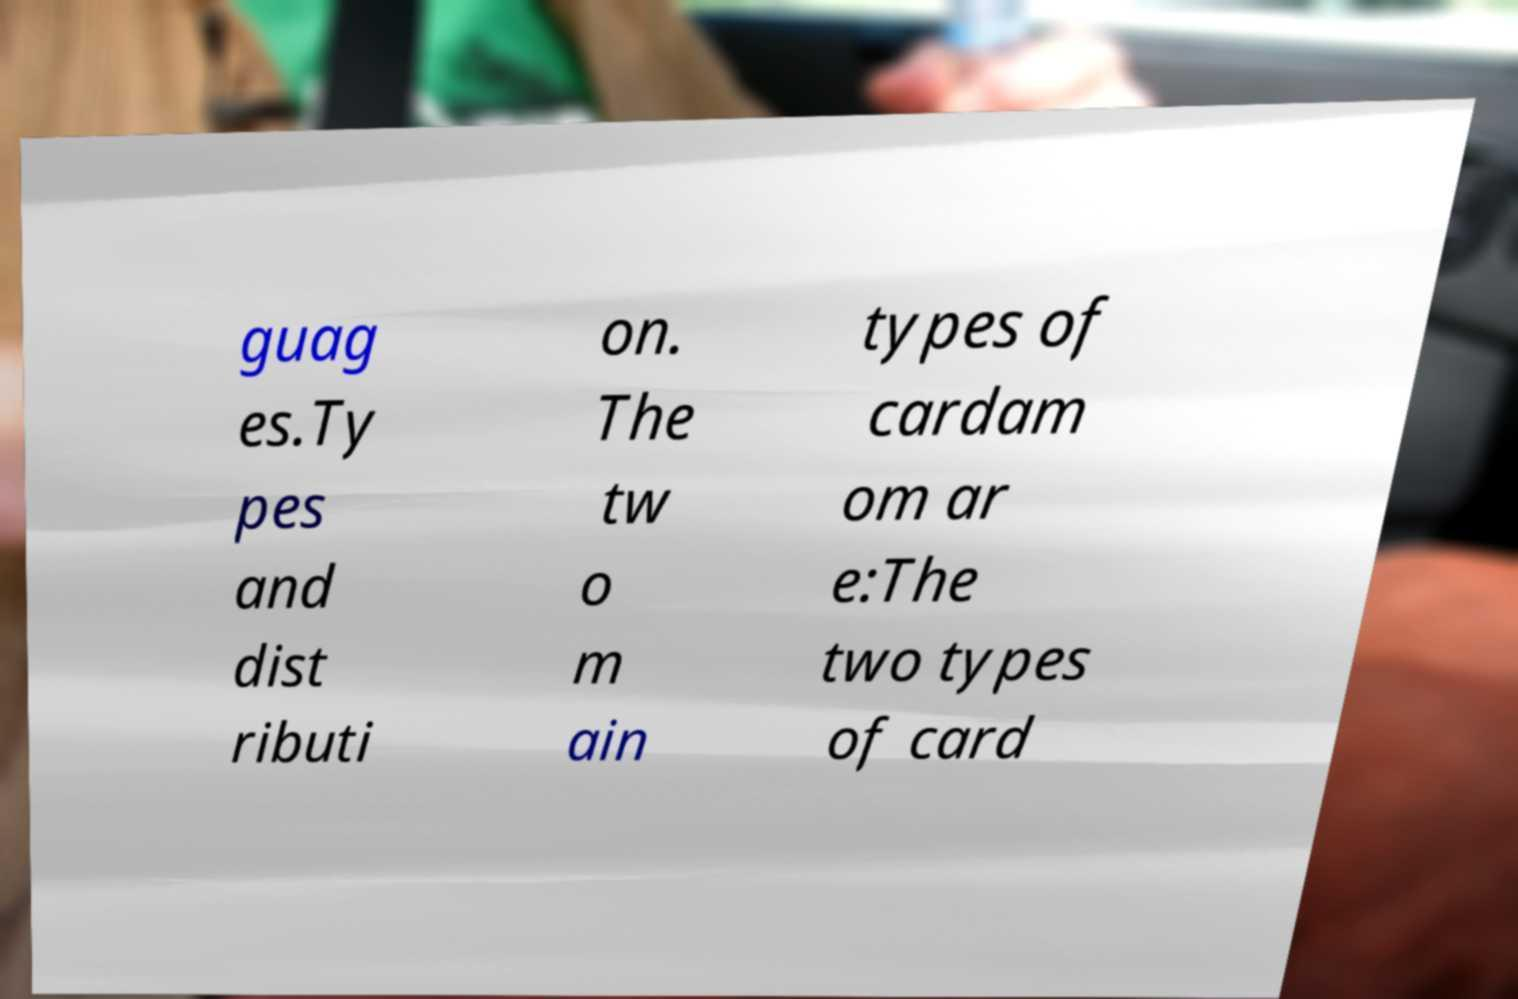Please read and relay the text visible in this image. What does it say? guag es.Ty pes and dist ributi on. The tw o m ain types of cardam om ar e:The two types of card 